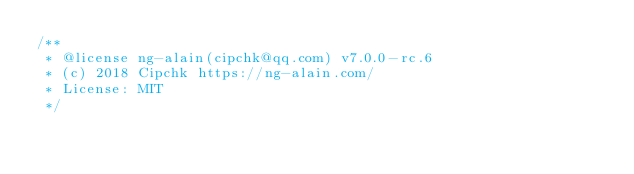<code> <loc_0><loc_0><loc_500><loc_500><_JavaScript_>/**
 * @license ng-alain(cipchk@qq.com) v7.0.0-rc.6
 * (c) 2018 Cipchk https://ng-alain.com/
 * License: MIT
 */</code> 